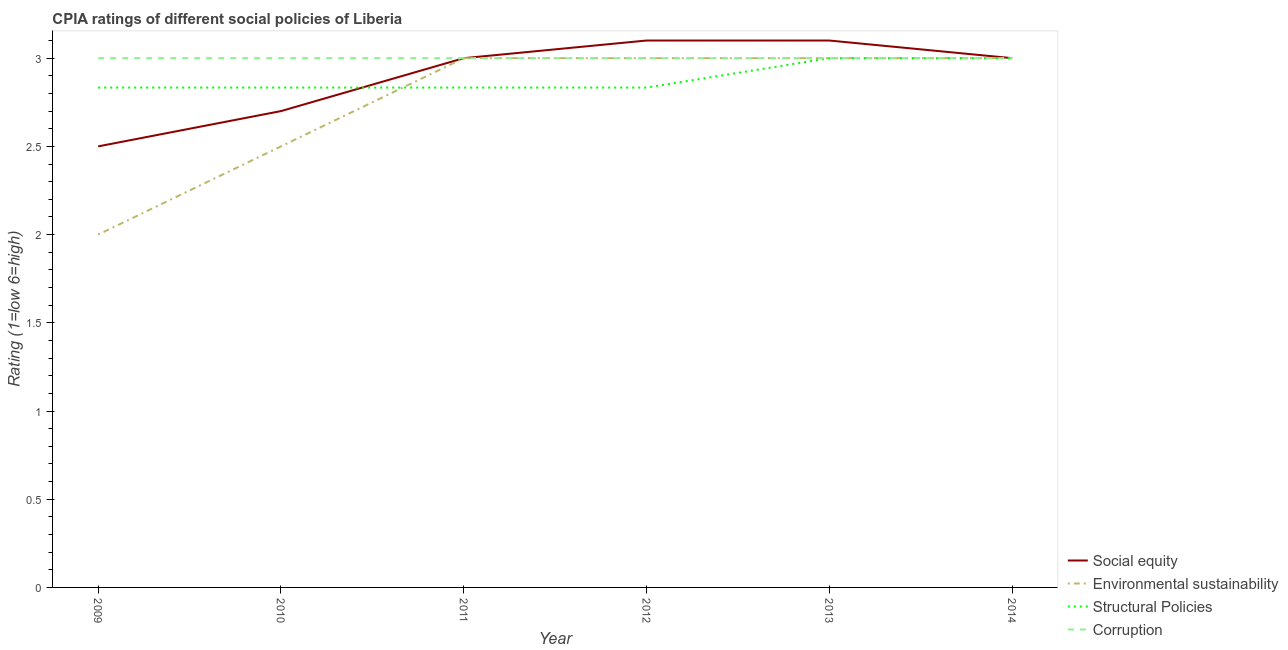How many different coloured lines are there?
Offer a terse response. 4. What is the cpia rating of structural policies in 2009?
Provide a succinct answer. 2.83. Across all years, what is the minimum cpia rating of corruption?
Provide a short and direct response. 3. In which year was the cpia rating of environmental sustainability maximum?
Make the answer very short. 2011. In which year was the cpia rating of social equity minimum?
Make the answer very short. 2009. What is the total cpia rating of corruption in the graph?
Offer a very short reply. 18. What is the difference between the cpia rating of structural policies in 2012 and the cpia rating of corruption in 2013?
Provide a short and direct response. -0.17. What is the average cpia rating of environmental sustainability per year?
Give a very brief answer. 2.75. In the year 2014, what is the difference between the cpia rating of structural policies and cpia rating of environmental sustainability?
Offer a terse response. 0. In how many years, is the cpia rating of corruption greater than 1.3?
Provide a short and direct response. 6. Is the cpia rating of social equity in 2010 less than that in 2012?
Your response must be concise. Yes. Is the difference between the cpia rating of environmental sustainability in 2012 and 2014 greater than the difference between the cpia rating of structural policies in 2012 and 2014?
Give a very brief answer. Yes. What is the difference between the highest and the second highest cpia rating of social equity?
Offer a terse response. 0. Is the sum of the cpia rating of structural policies in 2009 and 2014 greater than the maximum cpia rating of corruption across all years?
Your answer should be compact. Yes. Is it the case that in every year, the sum of the cpia rating of structural policies and cpia rating of social equity is greater than the sum of cpia rating of environmental sustainability and cpia rating of corruption?
Your answer should be compact. No. Does the cpia rating of structural policies monotonically increase over the years?
Keep it short and to the point. No. Is the cpia rating of corruption strictly less than the cpia rating of environmental sustainability over the years?
Offer a terse response. No. How many years are there in the graph?
Provide a succinct answer. 6. Are the values on the major ticks of Y-axis written in scientific E-notation?
Provide a short and direct response. No. Does the graph contain any zero values?
Your answer should be compact. No. Does the graph contain grids?
Keep it short and to the point. No. How many legend labels are there?
Give a very brief answer. 4. How are the legend labels stacked?
Keep it short and to the point. Vertical. What is the title of the graph?
Your answer should be very brief. CPIA ratings of different social policies of Liberia. Does "Source data assessment" appear as one of the legend labels in the graph?
Make the answer very short. No. What is the label or title of the X-axis?
Your answer should be very brief. Year. What is the Rating (1=low 6=high) of Social equity in 2009?
Give a very brief answer. 2.5. What is the Rating (1=low 6=high) in Environmental sustainability in 2009?
Ensure brevity in your answer.  2. What is the Rating (1=low 6=high) in Structural Policies in 2009?
Give a very brief answer. 2.83. What is the Rating (1=low 6=high) of Social equity in 2010?
Offer a terse response. 2.7. What is the Rating (1=low 6=high) of Environmental sustainability in 2010?
Make the answer very short. 2.5. What is the Rating (1=low 6=high) of Structural Policies in 2010?
Your answer should be very brief. 2.83. What is the Rating (1=low 6=high) of Social equity in 2011?
Provide a short and direct response. 3. What is the Rating (1=low 6=high) in Environmental sustainability in 2011?
Your answer should be compact. 3. What is the Rating (1=low 6=high) of Structural Policies in 2011?
Provide a succinct answer. 2.83. What is the Rating (1=low 6=high) in Environmental sustainability in 2012?
Offer a very short reply. 3. What is the Rating (1=low 6=high) in Structural Policies in 2012?
Your answer should be compact. 2.83. What is the Rating (1=low 6=high) in Corruption in 2012?
Your answer should be compact. 3. What is the Rating (1=low 6=high) in Structural Policies in 2013?
Provide a short and direct response. 3. What is the Rating (1=low 6=high) in Corruption in 2013?
Your answer should be compact. 3. What is the Rating (1=low 6=high) in Environmental sustainability in 2014?
Provide a succinct answer. 3. What is the Rating (1=low 6=high) of Corruption in 2014?
Keep it short and to the point. 3. Across all years, what is the maximum Rating (1=low 6=high) of Environmental sustainability?
Your response must be concise. 3. Across all years, what is the minimum Rating (1=low 6=high) of Environmental sustainability?
Your response must be concise. 2. Across all years, what is the minimum Rating (1=low 6=high) in Structural Policies?
Provide a short and direct response. 2.83. What is the total Rating (1=low 6=high) in Environmental sustainability in the graph?
Offer a very short reply. 16.5. What is the total Rating (1=low 6=high) of Structural Policies in the graph?
Offer a very short reply. 17.33. What is the difference between the Rating (1=low 6=high) of Environmental sustainability in 2009 and that in 2010?
Your answer should be compact. -0.5. What is the difference between the Rating (1=low 6=high) in Structural Policies in 2009 and that in 2010?
Give a very brief answer. 0. What is the difference between the Rating (1=low 6=high) of Environmental sustainability in 2009 and that in 2011?
Provide a short and direct response. -1. What is the difference between the Rating (1=low 6=high) in Structural Policies in 2009 and that in 2011?
Offer a very short reply. 0. What is the difference between the Rating (1=low 6=high) in Social equity in 2009 and that in 2012?
Your answer should be compact. -0.6. What is the difference between the Rating (1=low 6=high) of Structural Policies in 2009 and that in 2012?
Offer a terse response. 0. What is the difference between the Rating (1=low 6=high) in Social equity in 2009 and that in 2013?
Your response must be concise. -0.6. What is the difference between the Rating (1=low 6=high) of Corruption in 2009 and that in 2013?
Give a very brief answer. 0. What is the difference between the Rating (1=low 6=high) in Social equity in 2009 and that in 2014?
Your response must be concise. -0.5. What is the difference between the Rating (1=low 6=high) in Structural Policies in 2009 and that in 2014?
Your answer should be compact. -0.17. What is the difference between the Rating (1=low 6=high) of Corruption in 2009 and that in 2014?
Your response must be concise. 0. What is the difference between the Rating (1=low 6=high) in Social equity in 2010 and that in 2011?
Provide a succinct answer. -0.3. What is the difference between the Rating (1=low 6=high) of Environmental sustainability in 2010 and that in 2011?
Make the answer very short. -0.5. What is the difference between the Rating (1=low 6=high) in Social equity in 2010 and that in 2012?
Ensure brevity in your answer.  -0.4. What is the difference between the Rating (1=low 6=high) in Corruption in 2010 and that in 2012?
Provide a short and direct response. 0. What is the difference between the Rating (1=low 6=high) in Social equity in 2010 and that in 2013?
Ensure brevity in your answer.  -0.4. What is the difference between the Rating (1=low 6=high) in Environmental sustainability in 2010 and that in 2013?
Keep it short and to the point. -0.5. What is the difference between the Rating (1=low 6=high) of Corruption in 2010 and that in 2013?
Keep it short and to the point. 0. What is the difference between the Rating (1=low 6=high) in Environmental sustainability in 2010 and that in 2014?
Provide a short and direct response. -0.5. What is the difference between the Rating (1=low 6=high) of Structural Policies in 2010 and that in 2014?
Ensure brevity in your answer.  -0.17. What is the difference between the Rating (1=low 6=high) in Corruption in 2010 and that in 2014?
Provide a short and direct response. 0. What is the difference between the Rating (1=low 6=high) in Social equity in 2011 and that in 2012?
Your answer should be compact. -0.1. What is the difference between the Rating (1=low 6=high) in Environmental sustainability in 2011 and that in 2012?
Make the answer very short. 0. What is the difference between the Rating (1=low 6=high) in Corruption in 2011 and that in 2012?
Your answer should be compact. 0. What is the difference between the Rating (1=low 6=high) in Social equity in 2011 and that in 2013?
Make the answer very short. -0.1. What is the difference between the Rating (1=low 6=high) of Corruption in 2011 and that in 2013?
Provide a succinct answer. 0. What is the difference between the Rating (1=low 6=high) in Environmental sustainability in 2011 and that in 2014?
Ensure brevity in your answer.  0. What is the difference between the Rating (1=low 6=high) of Structural Policies in 2011 and that in 2014?
Offer a very short reply. -0.17. What is the difference between the Rating (1=low 6=high) of Environmental sustainability in 2012 and that in 2013?
Offer a terse response. 0. What is the difference between the Rating (1=low 6=high) in Corruption in 2012 and that in 2014?
Provide a succinct answer. 0. What is the difference between the Rating (1=low 6=high) of Social equity in 2013 and that in 2014?
Keep it short and to the point. 0.1. What is the difference between the Rating (1=low 6=high) of Environmental sustainability in 2013 and that in 2014?
Offer a terse response. 0. What is the difference between the Rating (1=low 6=high) in Social equity in 2009 and the Rating (1=low 6=high) in Structural Policies in 2010?
Your response must be concise. -0.33. What is the difference between the Rating (1=low 6=high) of Environmental sustainability in 2009 and the Rating (1=low 6=high) of Structural Policies in 2010?
Offer a very short reply. -0.83. What is the difference between the Rating (1=low 6=high) of Social equity in 2009 and the Rating (1=low 6=high) of Environmental sustainability in 2011?
Keep it short and to the point. -0.5. What is the difference between the Rating (1=low 6=high) in Environmental sustainability in 2009 and the Rating (1=low 6=high) in Corruption in 2011?
Give a very brief answer. -1. What is the difference between the Rating (1=low 6=high) of Structural Policies in 2009 and the Rating (1=low 6=high) of Corruption in 2011?
Give a very brief answer. -0.17. What is the difference between the Rating (1=low 6=high) in Social equity in 2009 and the Rating (1=low 6=high) in Environmental sustainability in 2012?
Ensure brevity in your answer.  -0.5. What is the difference between the Rating (1=low 6=high) of Social equity in 2009 and the Rating (1=low 6=high) of Corruption in 2012?
Provide a short and direct response. -0.5. What is the difference between the Rating (1=low 6=high) in Structural Policies in 2009 and the Rating (1=low 6=high) in Corruption in 2012?
Give a very brief answer. -0.17. What is the difference between the Rating (1=low 6=high) in Social equity in 2009 and the Rating (1=low 6=high) in Environmental sustainability in 2013?
Provide a short and direct response. -0.5. What is the difference between the Rating (1=low 6=high) of Social equity in 2009 and the Rating (1=low 6=high) of Corruption in 2013?
Make the answer very short. -0.5. What is the difference between the Rating (1=low 6=high) of Environmental sustainability in 2009 and the Rating (1=low 6=high) of Structural Policies in 2013?
Offer a very short reply. -1. What is the difference between the Rating (1=low 6=high) of Structural Policies in 2009 and the Rating (1=low 6=high) of Corruption in 2013?
Provide a succinct answer. -0.17. What is the difference between the Rating (1=low 6=high) of Social equity in 2009 and the Rating (1=low 6=high) of Environmental sustainability in 2014?
Keep it short and to the point. -0.5. What is the difference between the Rating (1=low 6=high) in Social equity in 2009 and the Rating (1=low 6=high) in Corruption in 2014?
Your response must be concise. -0.5. What is the difference between the Rating (1=low 6=high) in Environmental sustainability in 2009 and the Rating (1=low 6=high) in Structural Policies in 2014?
Offer a very short reply. -1. What is the difference between the Rating (1=low 6=high) in Environmental sustainability in 2009 and the Rating (1=low 6=high) in Corruption in 2014?
Provide a short and direct response. -1. What is the difference between the Rating (1=low 6=high) in Structural Policies in 2009 and the Rating (1=low 6=high) in Corruption in 2014?
Provide a succinct answer. -0.17. What is the difference between the Rating (1=low 6=high) in Social equity in 2010 and the Rating (1=low 6=high) in Environmental sustainability in 2011?
Ensure brevity in your answer.  -0.3. What is the difference between the Rating (1=low 6=high) of Social equity in 2010 and the Rating (1=low 6=high) of Structural Policies in 2011?
Provide a succinct answer. -0.13. What is the difference between the Rating (1=low 6=high) of Environmental sustainability in 2010 and the Rating (1=low 6=high) of Structural Policies in 2011?
Offer a very short reply. -0.33. What is the difference between the Rating (1=low 6=high) of Environmental sustainability in 2010 and the Rating (1=low 6=high) of Corruption in 2011?
Provide a succinct answer. -0.5. What is the difference between the Rating (1=low 6=high) in Social equity in 2010 and the Rating (1=low 6=high) in Environmental sustainability in 2012?
Keep it short and to the point. -0.3. What is the difference between the Rating (1=low 6=high) in Social equity in 2010 and the Rating (1=low 6=high) in Structural Policies in 2012?
Make the answer very short. -0.13. What is the difference between the Rating (1=low 6=high) in Social equity in 2010 and the Rating (1=low 6=high) in Corruption in 2012?
Make the answer very short. -0.3. What is the difference between the Rating (1=low 6=high) of Environmental sustainability in 2010 and the Rating (1=low 6=high) of Structural Policies in 2012?
Make the answer very short. -0.33. What is the difference between the Rating (1=low 6=high) in Structural Policies in 2010 and the Rating (1=low 6=high) in Corruption in 2012?
Ensure brevity in your answer.  -0.17. What is the difference between the Rating (1=low 6=high) in Social equity in 2010 and the Rating (1=low 6=high) in Structural Policies in 2013?
Provide a short and direct response. -0.3. What is the difference between the Rating (1=low 6=high) in Social equity in 2010 and the Rating (1=low 6=high) in Environmental sustainability in 2014?
Offer a very short reply. -0.3. What is the difference between the Rating (1=low 6=high) of Social equity in 2010 and the Rating (1=low 6=high) of Structural Policies in 2014?
Provide a short and direct response. -0.3. What is the difference between the Rating (1=low 6=high) in Social equity in 2010 and the Rating (1=low 6=high) in Corruption in 2014?
Ensure brevity in your answer.  -0.3. What is the difference between the Rating (1=low 6=high) in Environmental sustainability in 2010 and the Rating (1=low 6=high) in Structural Policies in 2014?
Make the answer very short. -0.5. What is the difference between the Rating (1=low 6=high) of Environmental sustainability in 2010 and the Rating (1=low 6=high) of Corruption in 2014?
Keep it short and to the point. -0.5. What is the difference between the Rating (1=low 6=high) in Structural Policies in 2010 and the Rating (1=low 6=high) in Corruption in 2014?
Offer a very short reply. -0.17. What is the difference between the Rating (1=low 6=high) in Social equity in 2011 and the Rating (1=low 6=high) in Environmental sustainability in 2012?
Offer a very short reply. 0. What is the difference between the Rating (1=low 6=high) of Social equity in 2011 and the Rating (1=low 6=high) of Corruption in 2012?
Your answer should be compact. 0. What is the difference between the Rating (1=low 6=high) in Environmental sustainability in 2011 and the Rating (1=low 6=high) in Structural Policies in 2012?
Make the answer very short. 0.17. What is the difference between the Rating (1=low 6=high) of Environmental sustainability in 2011 and the Rating (1=low 6=high) of Corruption in 2012?
Offer a very short reply. 0. What is the difference between the Rating (1=low 6=high) in Social equity in 2011 and the Rating (1=low 6=high) in Environmental sustainability in 2013?
Ensure brevity in your answer.  0. What is the difference between the Rating (1=low 6=high) in Social equity in 2011 and the Rating (1=low 6=high) in Corruption in 2013?
Offer a terse response. 0. What is the difference between the Rating (1=low 6=high) in Environmental sustainability in 2011 and the Rating (1=low 6=high) in Structural Policies in 2013?
Offer a very short reply. 0. What is the difference between the Rating (1=low 6=high) of Social equity in 2011 and the Rating (1=low 6=high) of Environmental sustainability in 2014?
Give a very brief answer. 0. What is the difference between the Rating (1=low 6=high) of Social equity in 2011 and the Rating (1=low 6=high) of Corruption in 2014?
Keep it short and to the point. 0. What is the difference between the Rating (1=low 6=high) in Environmental sustainability in 2011 and the Rating (1=low 6=high) in Structural Policies in 2014?
Provide a short and direct response. 0. What is the difference between the Rating (1=low 6=high) of Social equity in 2012 and the Rating (1=low 6=high) of Environmental sustainability in 2013?
Ensure brevity in your answer.  0.1. What is the difference between the Rating (1=low 6=high) of Social equity in 2012 and the Rating (1=low 6=high) of Structural Policies in 2013?
Your response must be concise. 0.1. What is the difference between the Rating (1=low 6=high) of Social equity in 2012 and the Rating (1=low 6=high) of Corruption in 2013?
Offer a terse response. 0.1. What is the difference between the Rating (1=low 6=high) in Social equity in 2012 and the Rating (1=low 6=high) in Structural Policies in 2014?
Keep it short and to the point. 0.1. What is the difference between the Rating (1=low 6=high) in Social equity in 2012 and the Rating (1=low 6=high) in Corruption in 2014?
Give a very brief answer. 0.1. What is the difference between the Rating (1=low 6=high) in Environmental sustainability in 2012 and the Rating (1=low 6=high) in Corruption in 2014?
Your answer should be compact. 0. What is the difference between the Rating (1=low 6=high) in Structural Policies in 2012 and the Rating (1=low 6=high) in Corruption in 2014?
Provide a short and direct response. -0.17. What is the difference between the Rating (1=low 6=high) of Social equity in 2013 and the Rating (1=low 6=high) of Structural Policies in 2014?
Give a very brief answer. 0.1. What is the difference between the Rating (1=low 6=high) in Environmental sustainability in 2013 and the Rating (1=low 6=high) in Corruption in 2014?
Offer a terse response. 0. What is the average Rating (1=low 6=high) in Social equity per year?
Provide a short and direct response. 2.9. What is the average Rating (1=low 6=high) in Environmental sustainability per year?
Give a very brief answer. 2.75. What is the average Rating (1=low 6=high) in Structural Policies per year?
Provide a succinct answer. 2.89. In the year 2009, what is the difference between the Rating (1=low 6=high) in Social equity and Rating (1=low 6=high) in Environmental sustainability?
Make the answer very short. 0.5. In the year 2009, what is the difference between the Rating (1=low 6=high) in Social equity and Rating (1=low 6=high) in Structural Policies?
Your answer should be very brief. -0.33. In the year 2009, what is the difference between the Rating (1=low 6=high) in Environmental sustainability and Rating (1=low 6=high) in Corruption?
Provide a short and direct response. -1. In the year 2010, what is the difference between the Rating (1=low 6=high) of Social equity and Rating (1=low 6=high) of Environmental sustainability?
Give a very brief answer. 0.2. In the year 2010, what is the difference between the Rating (1=low 6=high) of Social equity and Rating (1=low 6=high) of Structural Policies?
Make the answer very short. -0.13. In the year 2010, what is the difference between the Rating (1=low 6=high) in Environmental sustainability and Rating (1=low 6=high) in Structural Policies?
Your answer should be compact. -0.33. In the year 2010, what is the difference between the Rating (1=low 6=high) of Environmental sustainability and Rating (1=low 6=high) of Corruption?
Your answer should be compact. -0.5. In the year 2011, what is the difference between the Rating (1=low 6=high) in Social equity and Rating (1=low 6=high) in Environmental sustainability?
Keep it short and to the point. 0. In the year 2011, what is the difference between the Rating (1=low 6=high) of Environmental sustainability and Rating (1=low 6=high) of Corruption?
Provide a succinct answer. 0. In the year 2012, what is the difference between the Rating (1=low 6=high) of Social equity and Rating (1=low 6=high) of Environmental sustainability?
Your answer should be very brief. 0.1. In the year 2012, what is the difference between the Rating (1=low 6=high) of Social equity and Rating (1=low 6=high) of Structural Policies?
Your answer should be very brief. 0.27. In the year 2012, what is the difference between the Rating (1=low 6=high) in Social equity and Rating (1=low 6=high) in Corruption?
Provide a short and direct response. 0.1. In the year 2013, what is the difference between the Rating (1=low 6=high) of Social equity and Rating (1=low 6=high) of Structural Policies?
Your answer should be compact. 0.1. In the year 2013, what is the difference between the Rating (1=low 6=high) in Environmental sustainability and Rating (1=low 6=high) in Structural Policies?
Offer a very short reply. 0. What is the ratio of the Rating (1=low 6=high) in Social equity in 2009 to that in 2010?
Offer a very short reply. 0.93. What is the ratio of the Rating (1=low 6=high) of Corruption in 2009 to that in 2010?
Your answer should be compact. 1. What is the ratio of the Rating (1=low 6=high) in Structural Policies in 2009 to that in 2011?
Give a very brief answer. 1. What is the ratio of the Rating (1=low 6=high) in Social equity in 2009 to that in 2012?
Your response must be concise. 0.81. What is the ratio of the Rating (1=low 6=high) in Structural Policies in 2009 to that in 2012?
Keep it short and to the point. 1. What is the ratio of the Rating (1=low 6=high) of Corruption in 2009 to that in 2012?
Provide a succinct answer. 1. What is the ratio of the Rating (1=low 6=high) of Social equity in 2009 to that in 2013?
Provide a succinct answer. 0.81. What is the ratio of the Rating (1=low 6=high) in Social equity in 2009 to that in 2014?
Your answer should be very brief. 0.83. What is the ratio of the Rating (1=low 6=high) of Structural Policies in 2009 to that in 2014?
Give a very brief answer. 0.94. What is the ratio of the Rating (1=low 6=high) of Social equity in 2010 to that in 2011?
Offer a very short reply. 0.9. What is the ratio of the Rating (1=low 6=high) in Corruption in 2010 to that in 2011?
Provide a succinct answer. 1. What is the ratio of the Rating (1=low 6=high) of Social equity in 2010 to that in 2012?
Keep it short and to the point. 0.87. What is the ratio of the Rating (1=low 6=high) in Environmental sustainability in 2010 to that in 2012?
Offer a very short reply. 0.83. What is the ratio of the Rating (1=low 6=high) in Structural Policies in 2010 to that in 2012?
Keep it short and to the point. 1. What is the ratio of the Rating (1=low 6=high) of Corruption in 2010 to that in 2012?
Your answer should be very brief. 1. What is the ratio of the Rating (1=low 6=high) in Social equity in 2010 to that in 2013?
Provide a short and direct response. 0.87. What is the ratio of the Rating (1=low 6=high) of Structural Policies in 2010 to that in 2013?
Your answer should be compact. 0.94. What is the ratio of the Rating (1=low 6=high) in Corruption in 2010 to that in 2013?
Make the answer very short. 1. What is the ratio of the Rating (1=low 6=high) in Social equity in 2010 to that in 2014?
Ensure brevity in your answer.  0.9. What is the ratio of the Rating (1=low 6=high) of Social equity in 2011 to that in 2012?
Keep it short and to the point. 0.97. What is the ratio of the Rating (1=low 6=high) in Environmental sustainability in 2011 to that in 2012?
Offer a very short reply. 1. What is the ratio of the Rating (1=low 6=high) in Corruption in 2011 to that in 2012?
Your answer should be very brief. 1. What is the ratio of the Rating (1=low 6=high) in Social equity in 2011 to that in 2013?
Give a very brief answer. 0.97. What is the ratio of the Rating (1=low 6=high) in Environmental sustainability in 2011 to that in 2014?
Your answer should be compact. 1. What is the ratio of the Rating (1=low 6=high) of Corruption in 2011 to that in 2014?
Offer a very short reply. 1. What is the ratio of the Rating (1=low 6=high) of Social equity in 2012 to that in 2013?
Give a very brief answer. 1. What is the ratio of the Rating (1=low 6=high) in Environmental sustainability in 2012 to that in 2014?
Provide a succinct answer. 1. What is the ratio of the Rating (1=low 6=high) of Structural Policies in 2012 to that in 2014?
Your answer should be compact. 0.94. What is the ratio of the Rating (1=low 6=high) of Structural Policies in 2013 to that in 2014?
Give a very brief answer. 1. What is the ratio of the Rating (1=low 6=high) in Corruption in 2013 to that in 2014?
Provide a short and direct response. 1. What is the difference between the highest and the second highest Rating (1=low 6=high) of Social equity?
Offer a terse response. 0. What is the difference between the highest and the second highest Rating (1=low 6=high) of Environmental sustainability?
Your answer should be compact. 0. What is the difference between the highest and the second highest Rating (1=low 6=high) of Corruption?
Offer a very short reply. 0. What is the difference between the highest and the lowest Rating (1=low 6=high) of Environmental sustainability?
Your response must be concise. 1. What is the difference between the highest and the lowest Rating (1=low 6=high) in Structural Policies?
Your answer should be very brief. 0.17. What is the difference between the highest and the lowest Rating (1=low 6=high) in Corruption?
Offer a terse response. 0. 